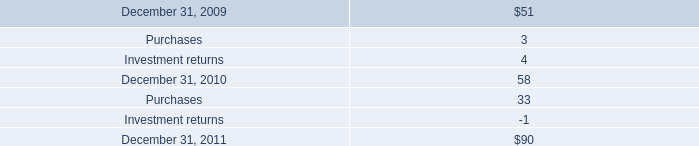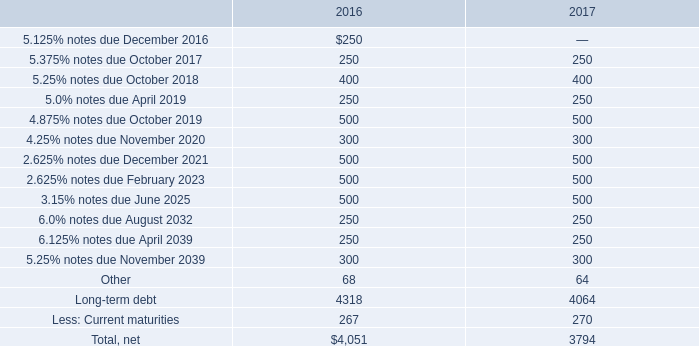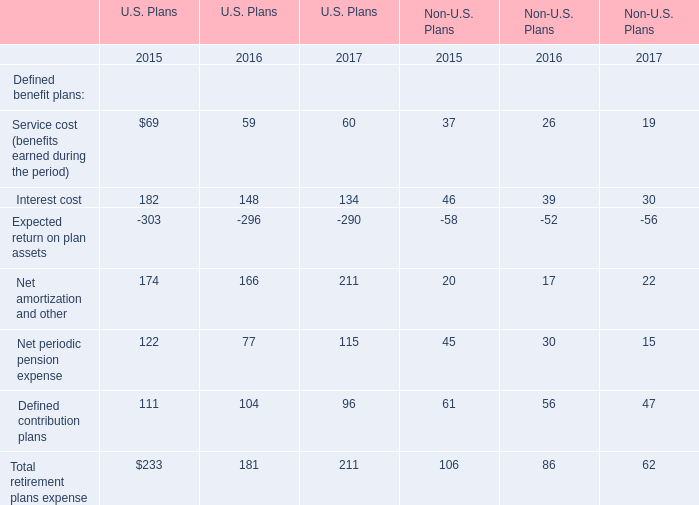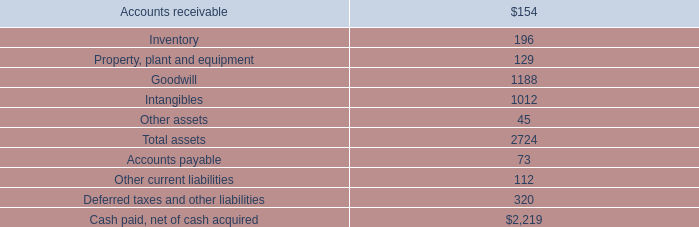What's the increasing rate of Net amortization and other in U.S. Plans in 2017? 
Computations: ((211 - 166) / 166)
Answer: 0.27108. 